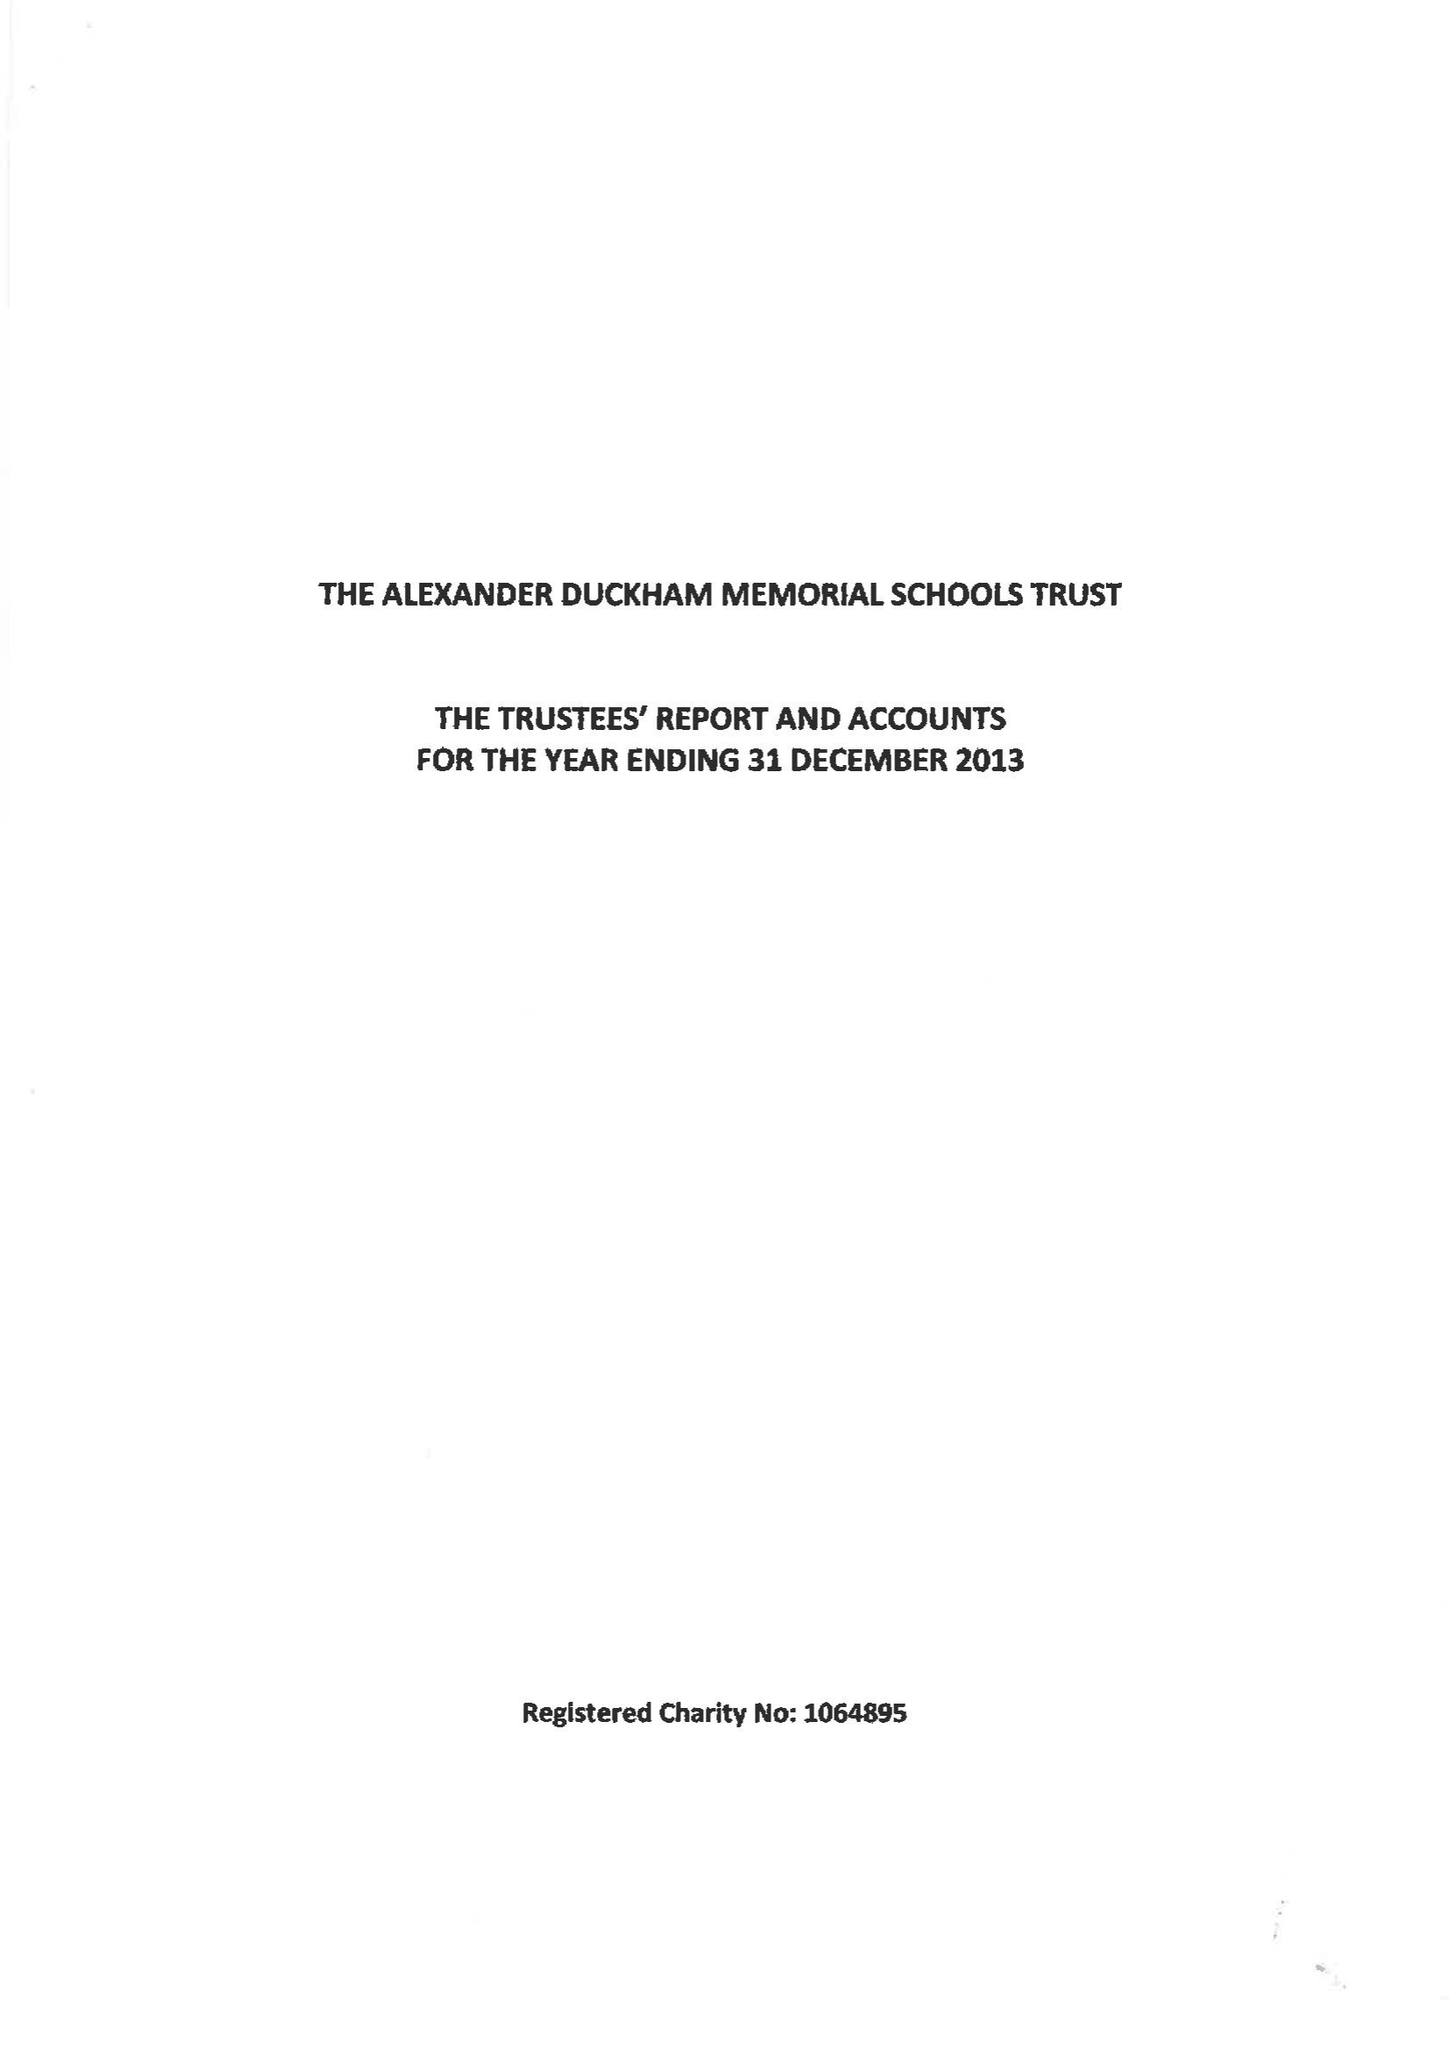What is the value for the address__street_line?
Answer the question using a single word or phrase. None 